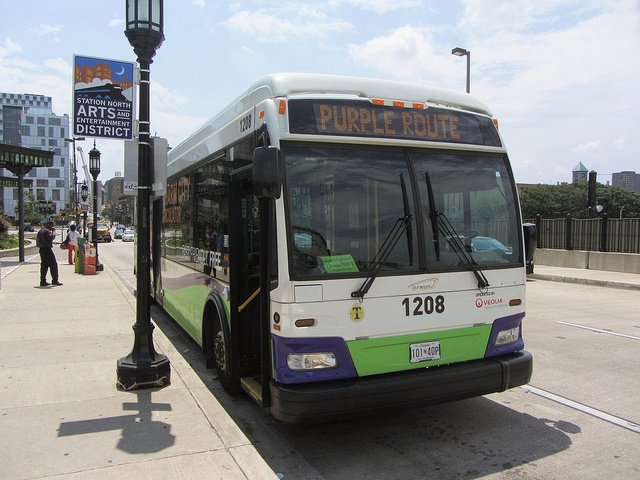Describe the objects in this image and their specific colors. I can see bus in lavender, black, gray, and darkgray tones, people in lavender, black, gray, purple, and darkgray tones, people in lavender, darkgray, maroon, black, and brown tones, truck in lavender, black, gray, and darkgray tones, and car in lavender, darkgray, lightgray, and gray tones in this image. 